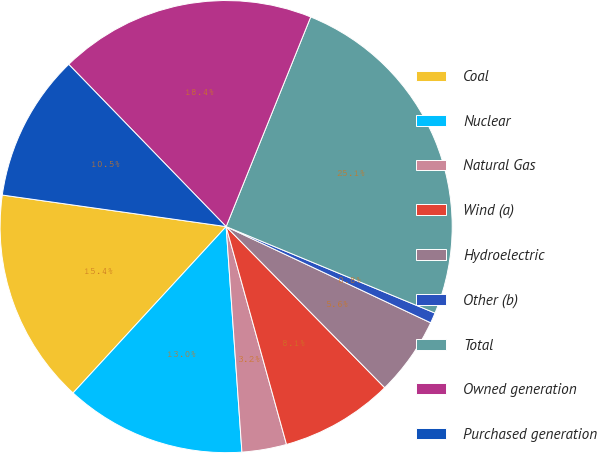Convert chart. <chart><loc_0><loc_0><loc_500><loc_500><pie_chart><fcel>Coal<fcel>Nuclear<fcel>Natural Gas<fcel>Wind (a)<fcel>Hydroelectric<fcel>Other (b)<fcel>Total<fcel>Owned generation<fcel>Purchased generation<nl><fcel>15.39%<fcel>12.95%<fcel>3.19%<fcel>8.07%<fcel>5.63%<fcel>0.75%<fcel>25.14%<fcel>18.36%<fcel>10.51%<nl></chart> 